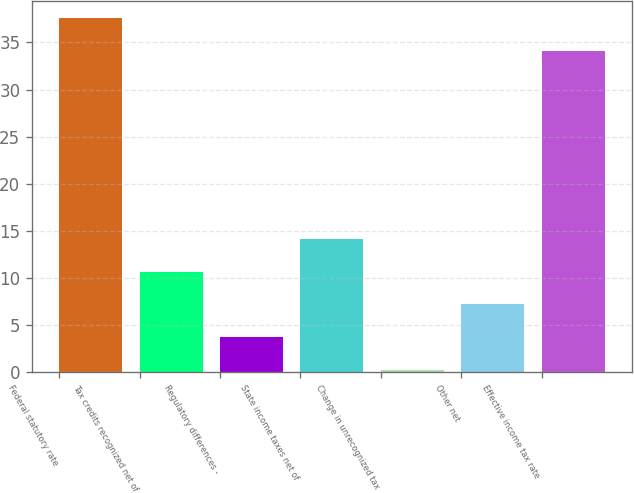Convert chart. <chart><loc_0><loc_0><loc_500><loc_500><bar_chart><fcel>Federal statutory rate<fcel>Tax credits recognized net of<fcel>Regulatory differences -<fcel>State income taxes net of<fcel>Change in unrecognized tax<fcel>Other net<fcel>Effective income tax rate<nl><fcel>37.58<fcel>10.64<fcel>3.68<fcel>14.12<fcel>0.2<fcel>7.16<fcel>34.1<nl></chart> 